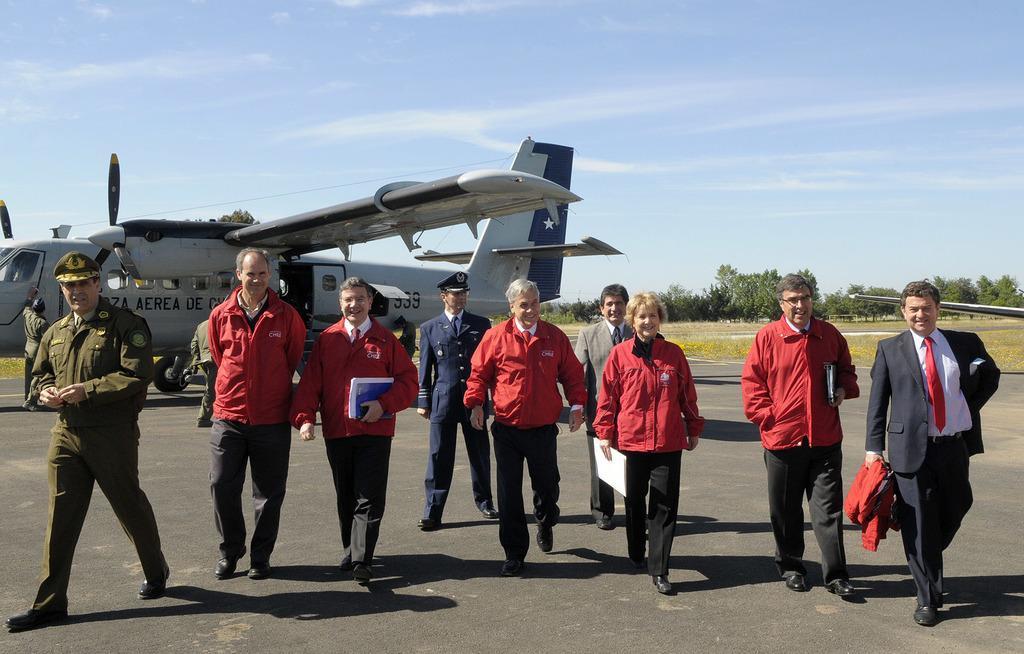How would you summarize this image in a sentence or two? In this picture we can see group of men and women wearing red color jacket are coming from the aircraft. Behind we can see a silver color aircraft and some trees. 